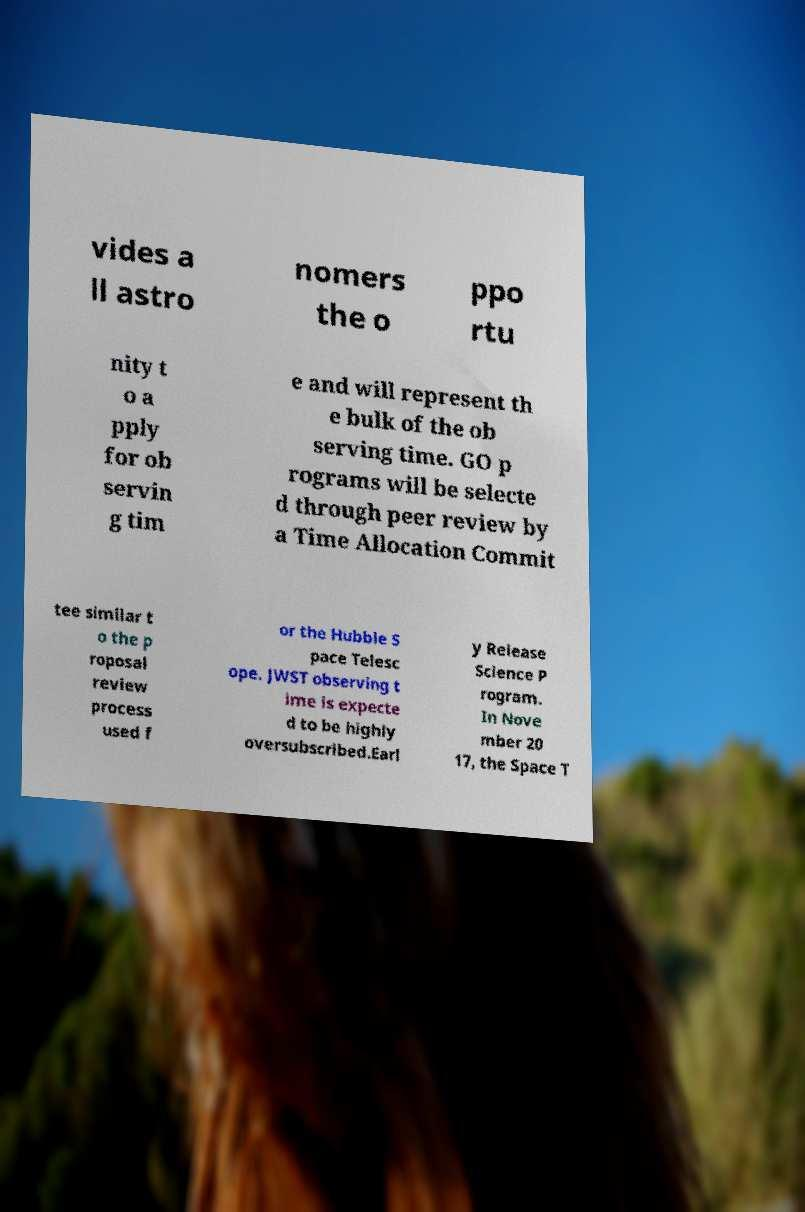For documentation purposes, I need the text within this image transcribed. Could you provide that? vides a ll astro nomers the o ppo rtu nity t o a pply for ob servin g tim e and will represent th e bulk of the ob serving time. GO p rograms will be selecte d through peer review by a Time Allocation Commit tee similar t o the p roposal review process used f or the Hubble S pace Telesc ope. JWST observing t ime is expecte d to be highly oversubscribed.Earl y Release Science P rogram. In Nove mber 20 17, the Space T 